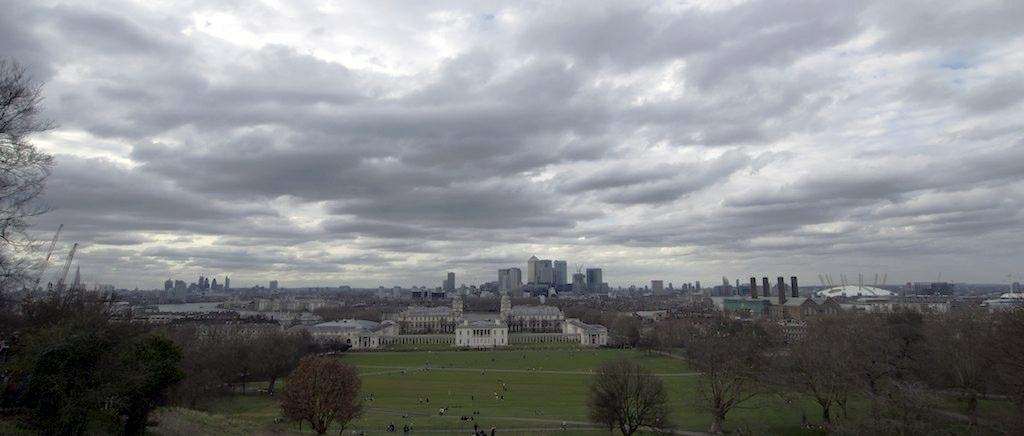What is the condition of the sky in the image? The sky is cloudy in the image. Who or what can be seen in the image? There are people in the image. What type of structures are visible in the image? There are buildings in the image. What type of vegetation is present in the image? Grass and trees are present in the image. How does the impulse affect the movement of the trees in the image? There is no mention of an impulse in the image, and the trees are not depicted as moving. 